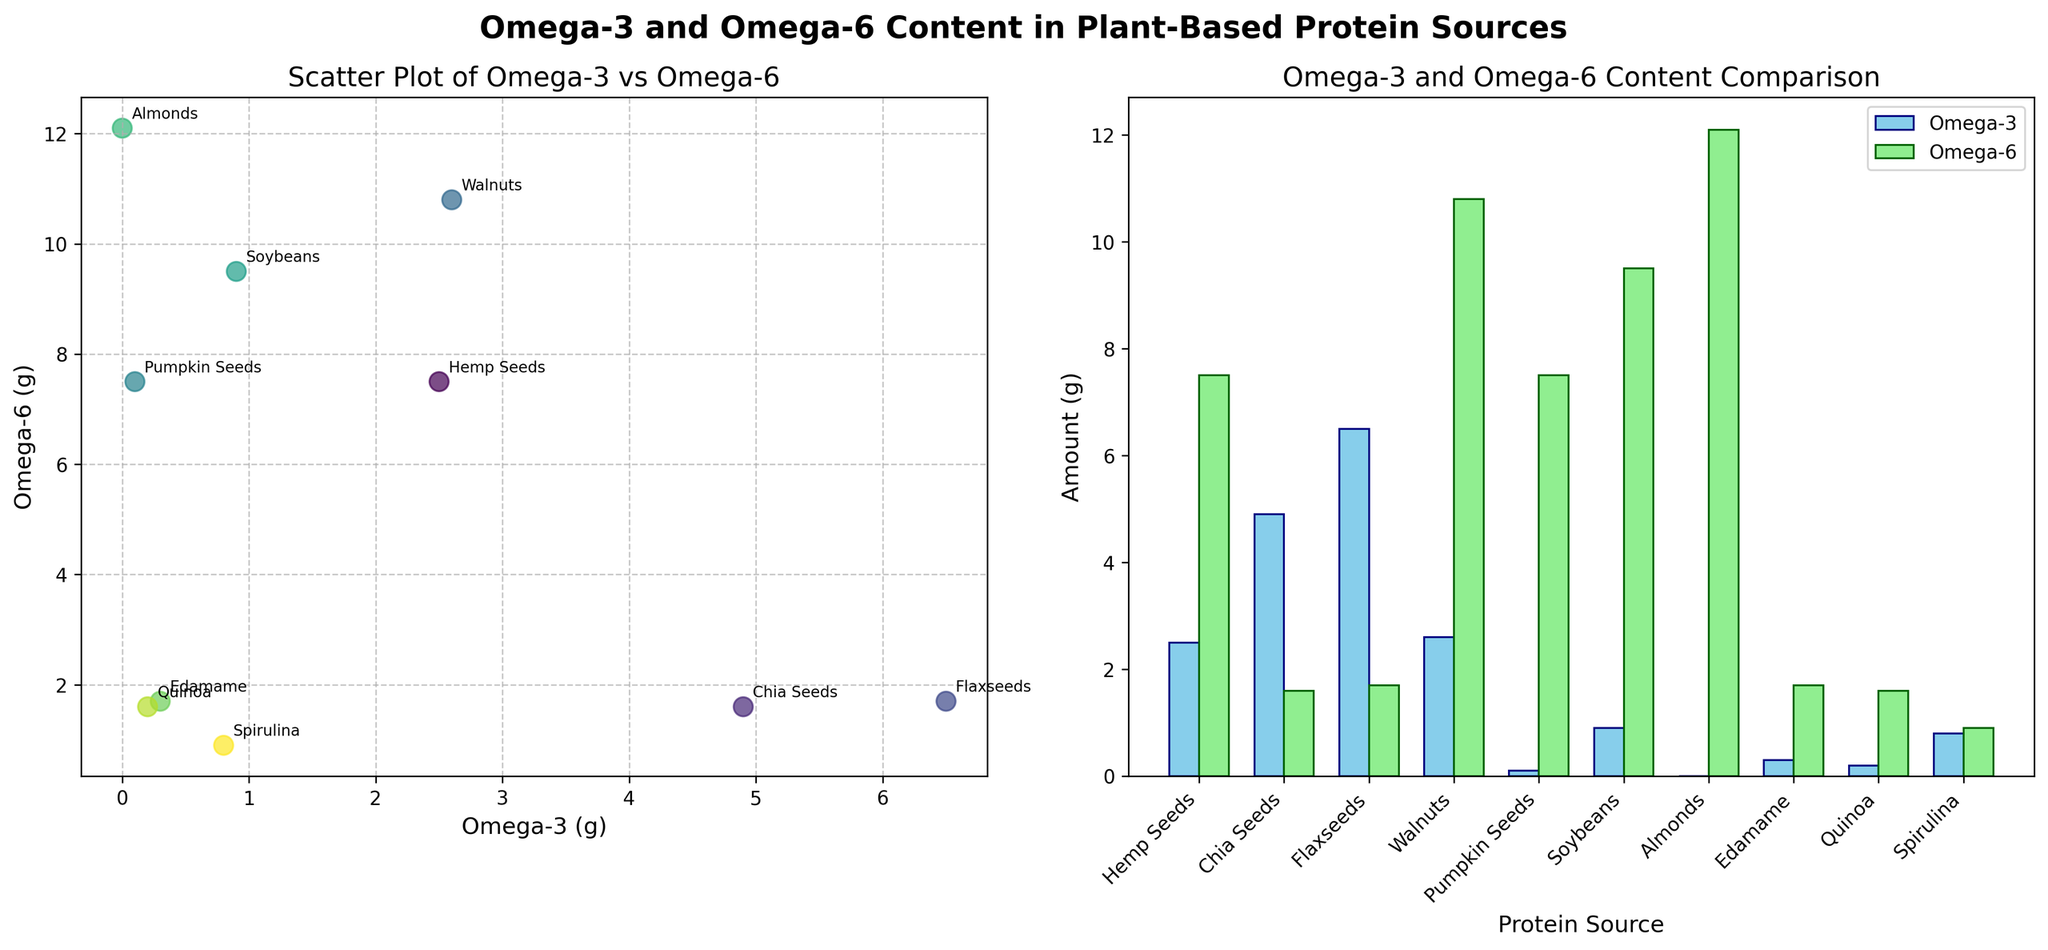What do the X and Y axes represent in the scatter plot? The X-axis represents the amount of Omega-3 in grams, and the Y-axis represents the amount of Omega-6 in grams.
Answer: Amount of Omega-3 (g) and amount of Omega-6 (g) What does the color gradient in the scatter plot represent? The color gradient in the scatter plot represents the different protein sources. Each source is assigned a unique color.
Answer: Unique colors for different protein sources Which protein source has the highest amount of Omega-3? The bar plot shows that Flaxseeds have the highest amount of Omega-3 at 6.5 grams.
Answer: Flaxseeds Which protein source has the highest amount of Omega-6? The bar plot indicates that Almonds have the highest amount of Omega-6 at 12.1 grams.
Answer: Almonds Which protein source is closest in Omega-3 content to Hemp Seeds but has a different Omega-6 content? In the scatter plot, Walnuts have an Omega-3 content close to Hemp Seeds but a higher Omega-6 content at 10.8 grams.
Answer: Walnuts What is the average Omega-3 content of all the protein sources? Sum the Omega-3 values: 2.5 + 4.9 + 6.5 + 2.6 + 0.1 + 0.9 + 0.0 + 0.3 + 0.2 + 0.8 = 18.8 grams. Divide by the number of sources (10): 18.8 / 10 = 1.88 grams.
Answer: 1.88 grams Which protein sources have a higher Omega-3 content than Hemp Seeds? From the bar plot, Chia Seeds (4.9 grams) and Flaxseeds (6.5 grams) have higher Omega-3 content than Hemp Seeds (2.5 grams).
Answer: Chia Seeds and Flaxseeds How does the Omega-3:Omega-6 ratio for Hemp Seeds compare to Chia Seeds? Hemp Seeds have a 1:3 ratio (2.5:7.5) whereas Chia Seeds have a 3:1 ratio (4.9:1.6).
Answer: 1:3 for Hemp Seeds, 3:1 for Chia Seeds Which protein source has the smallest difference between Omega-3 and Omega-6 content? In the scatter plot, Spirulina has the smallest difference between Omega-3 (0.8 grams) and Omega-6 (0.9 grams).
Answer: Spirulina How many protein sources have an Omega-3 content of 1 gram or more? From the bar plot, the following have Omega-3 content ≥ 1 gram: Hemp Seeds, Chia Seeds, Flaxseeds, Walnuts, and Spirulina. That's 5 sources.
Answer: 5 sources 